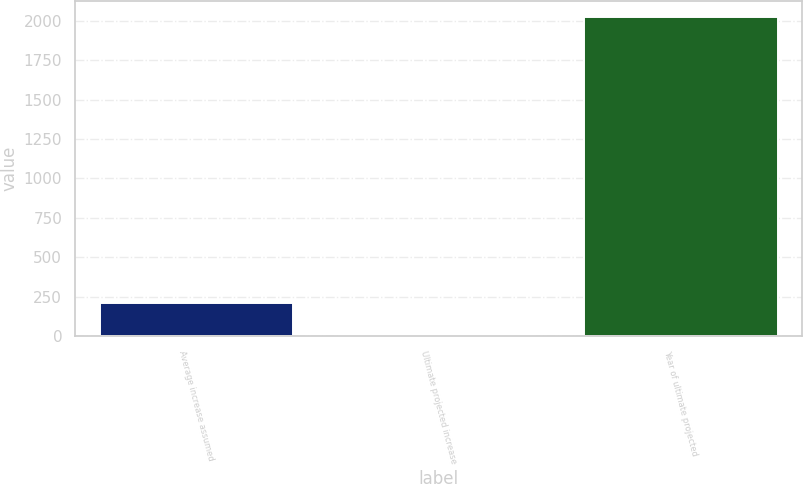<chart> <loc_0><loc_0><loc_500><loc_500><bar_chart><fcel>Average increase assumed<fcel>Ultimate projected increase<fcel>Year of ultimate projected<nl><fcel>207<fcel>5<fcel>2025<nl></chart> 